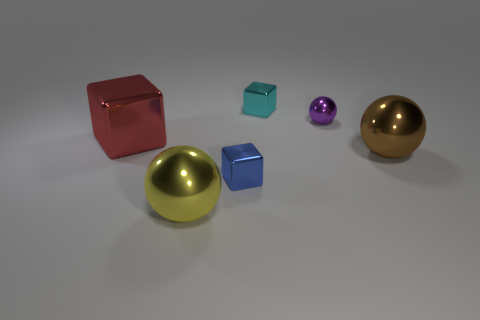Is there any other thing that is the same color as the big shiny cube?
Keep it short and to the point. No. There is a big ball to the right of the thing in front of the small blue cube; is there a cyan thing on the right side of it?
Make the answer very short. No. There is a tiny metal block that is behind the red shiny object; is it the same color as the small ball?
Ensure brevity in your answer.  No. How many blocks are either small purple things or small things?
Offer a very short reply. 2. There is a big shiny thing to the left of the sphere in front of the brown metallic ball; what is its shape?
Make the answer very short. Cube. There is a thing that is right of the small thing on the right side of the metal thing that is behind the purple shiny thing; what size is it?
Offer a very short reply. Large. Is the yellow shiny ball the same size as the purple metal object?
Your answer should be compact. No. How many objects are either tiny blue metal cubes or large yellow metallic balls?
Your answer should be very brief. 2. How big is the shiny cube that is left of the tiny metal object that is in front of the tiny metallic sphere?
Keep it short and to the point. Large. How big is the blue thing?
Keep it short and to the point. Small. 